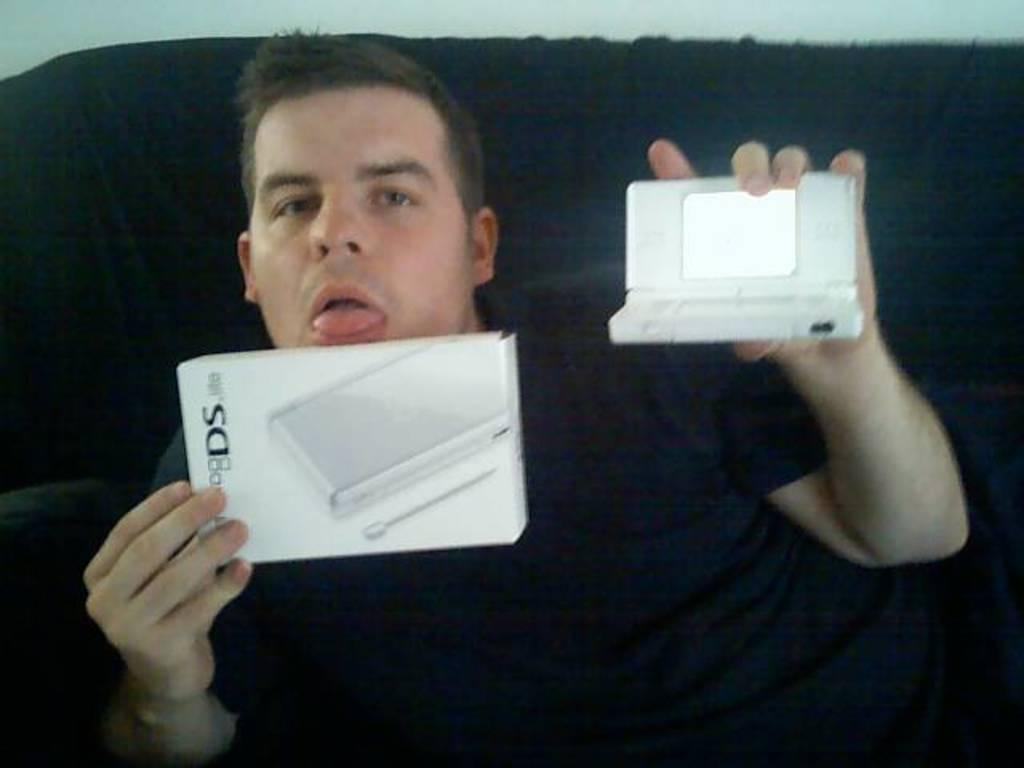Who is present in the image? There is a man in the image. What is the man doing in the image? The man is sitting on a sofa. What is the man holding in his hands? The man is holding objects in his hands. What can be seen in the background of the image? There is a wall in the background of the image. What type of shade is the man wearing in the image? There is no shade present in the image; the man is not wearing any headwear. 